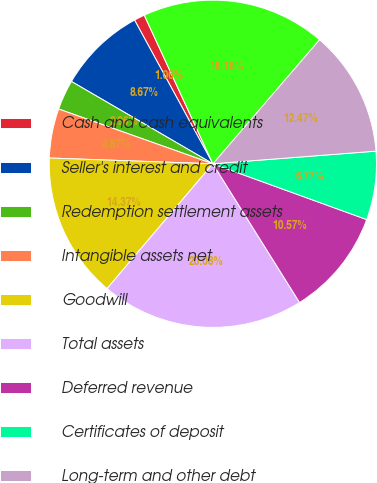Convert chart. <chart><loc_0><loc_0><loc_500><loc_500><pie_chart><fcel>Cash and cash equivalents<fcel>Seller's interest and credit<fcel>Redemption settlement assets<fcel>Intangible assets net<fcel>Goodwill<fcel>Total assets<fcel>Deferred revenue<fcel>Certificates of deposit<fcel>Long-term and other debt<fcel>Total liabilities<nl><fcel>1.06%<fcel>8.67%<fcel>2.96%<fcel>4.87%<fcel>14.37%<fcel>20.08%<fcel>10.57%<fcel>6.77%<fcel>12.47%<fcel>18.18%<nl></chart> 